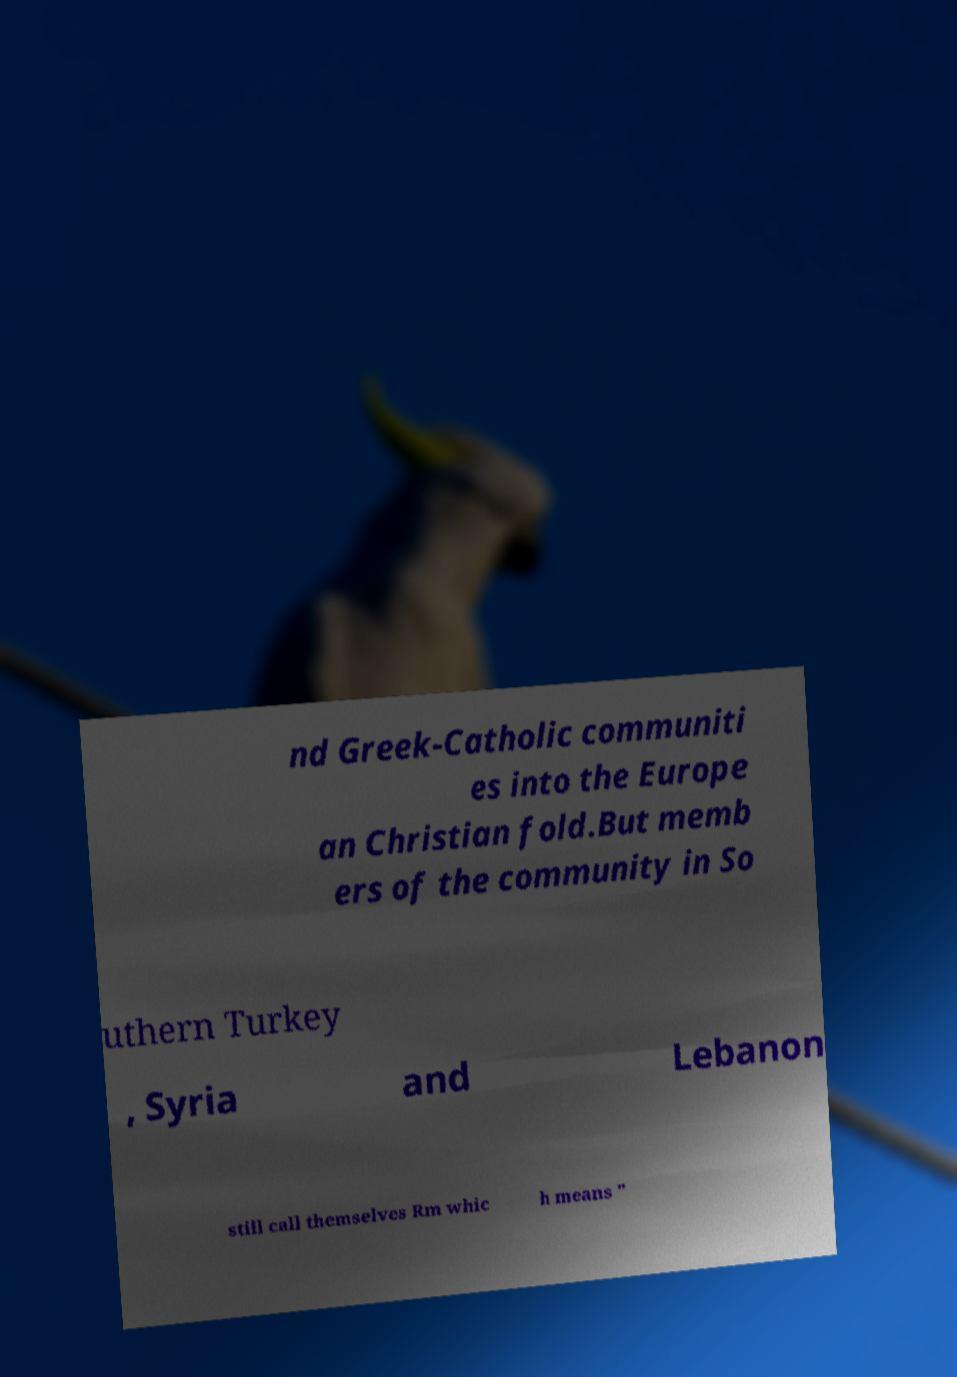There's text embedded in this image that I need extracted. Can you transcribe it verbatim? nd Greek-Catholic communiti es into the Europe an Christian fold.But memb ers of the community in So uthern Turkey , Syria and Lebanon still call themselves Rm whic h means " 